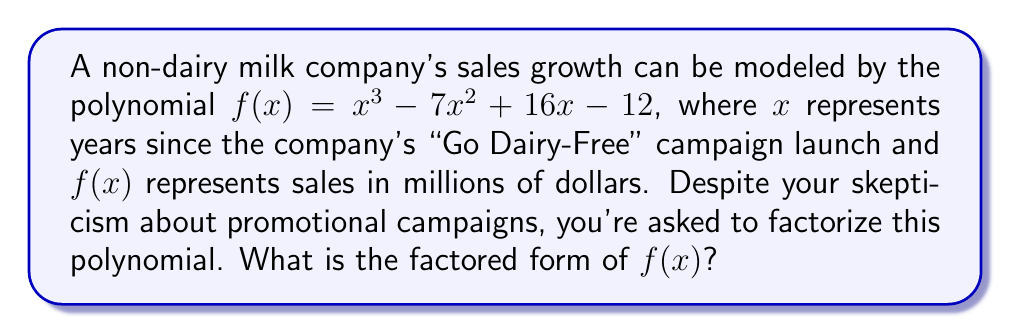Provide a solution to this math problem. Let's approach this step-by-step:

1) First, we'll check if there are any rational roots using the rational root theorem. The possible rational roots are the factors of the constant term: $\pm 1, \pm 2, \pm 3, \pm 4, \pm 6, \pm 12$

2) Testing these values, we find that $f(1) = 0$. So $(x-1)$ is a factor.

3) We can use polynomial long division to divide $f(x)$ by $(x-1)$:

   $x^3 - 7x^2 + 16x - 12 = (x-1)(x^2 - 6x + 12)$

4) Now we need to factor the quadratic $x^2 - 6x + 12$

5) The discriminant of this quadratic is $b^2 - 4ac = (-6)^2 - 4(1)(12) = 36 - 48 = -12$

6) Since the discriminant is negative, this quadratic doesn't have real roots. It can't be factored further over the real numbers.

7) Therefore, the complete factorization is:

   $f(x) = (x-1)(x^2 - 6x + 12)$

This factorization reveals that regardless of the company's campaign, sales will always be zero when $x=1$, i.e., one year after the campaign launch.
Answer: $(x-1)(x^2 - 6x + 12)$ 